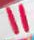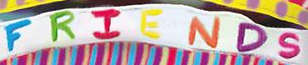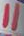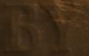Read the text content from these images in order, separated by a semicolon. "; FRIENDS; "; BY 